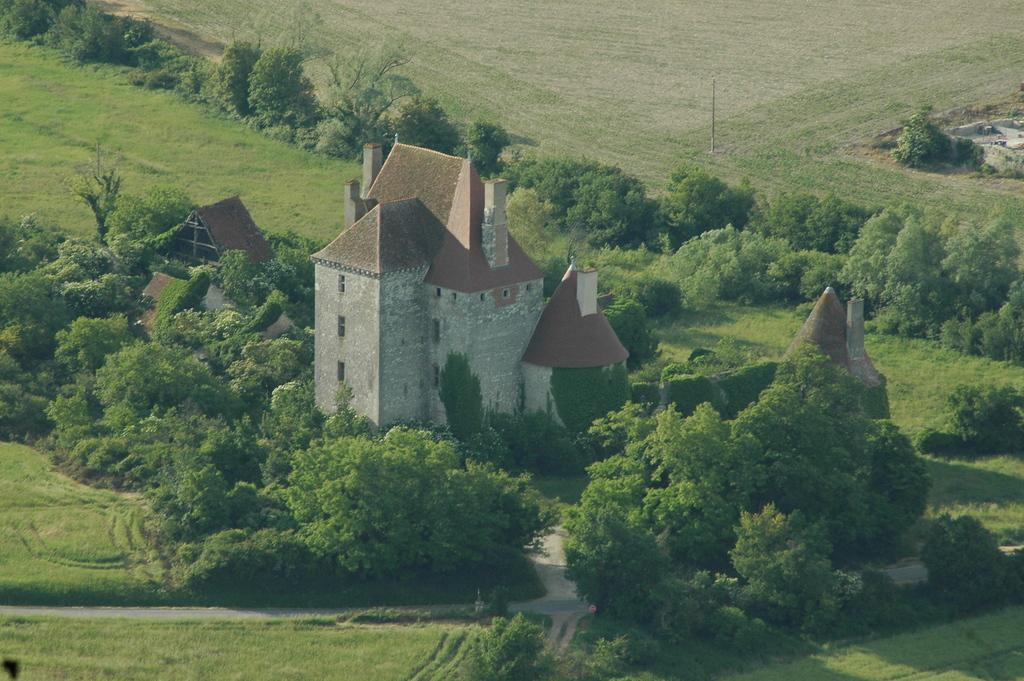What type of structures are visible in the image? There are houses in the image. What type of vegetation can be seen in the image? There are trees and grass in the image. What object is present in the image that might be used for support or signage? There is a pole in the image. Can you describe the time of day when the image was likely taken? The image was likely taken during the day, as there is sufficient light to see the houses, trees, grass, and pole. What type of pie is being served at the front of the image? There is no pie present in the image; it features houses, trees, grass, and a pole. 